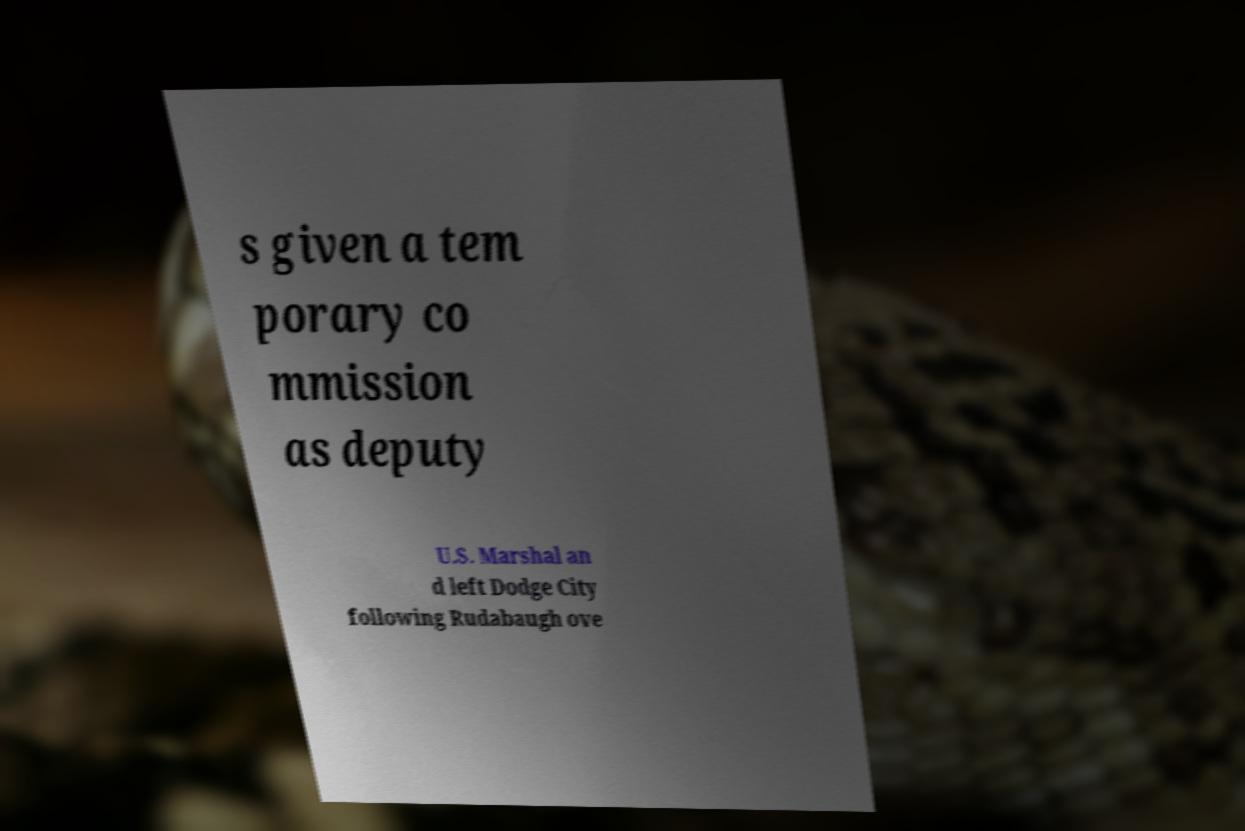Can you read and provide the text displayed in the image?This photo seems to have some interesting text. Can you extract and type it out for me? s given a tem porary co mmission as deputy U.S. Marshal an d left Dodge City following Rudabaugh ove 